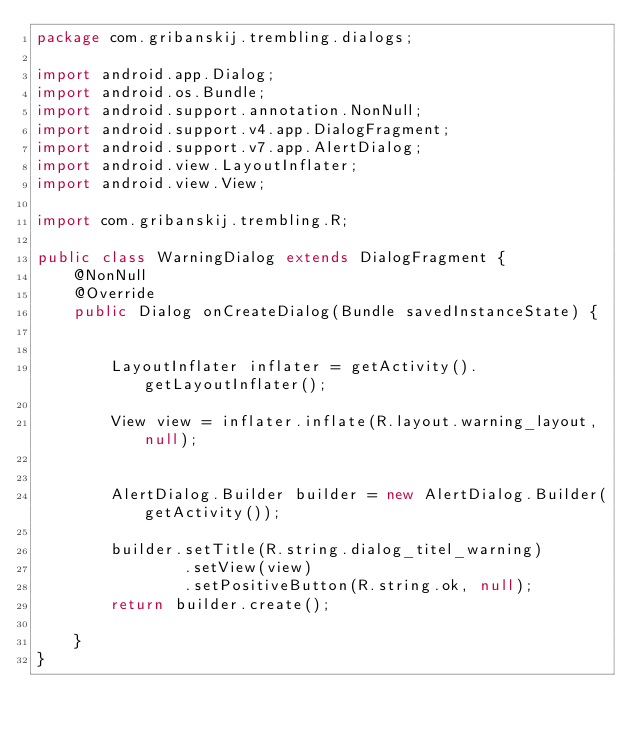<code> <loc_0><loc_0><loc_500><loc_500><_Java_>package com.gribanskij.trembling.dialogs;

import android.app.Dialog;
import android.os.Bundle;
import android.support.annotation.NonNull;
import android.support.v4.app.DialogFragment;
import android.support.v7.app.AlertDialog;
import android.view.LayoutInflater;
import android.view.View;

import com.gribanskij.trembling.R;

public class WarningDialog extends DialogFragment {
    @NonNull
    @Override
    public Dialog onCreateDialog(Bundle savedInstanceState) {


        LayoutInflater inflater = getActivity().getLayoutInflater();

        View view = inflater.inflate(R.layout.warning_layout, null);


        AlertDialog.Builder builder = new AlertDialog.Builder(getActivity());

        builder.setTitle(R.string.dialog_titel_warning)
                .setView(view)
                .setPositiveButton(R.string.ok, null);
        return builder.create();

    }
}
</code> 